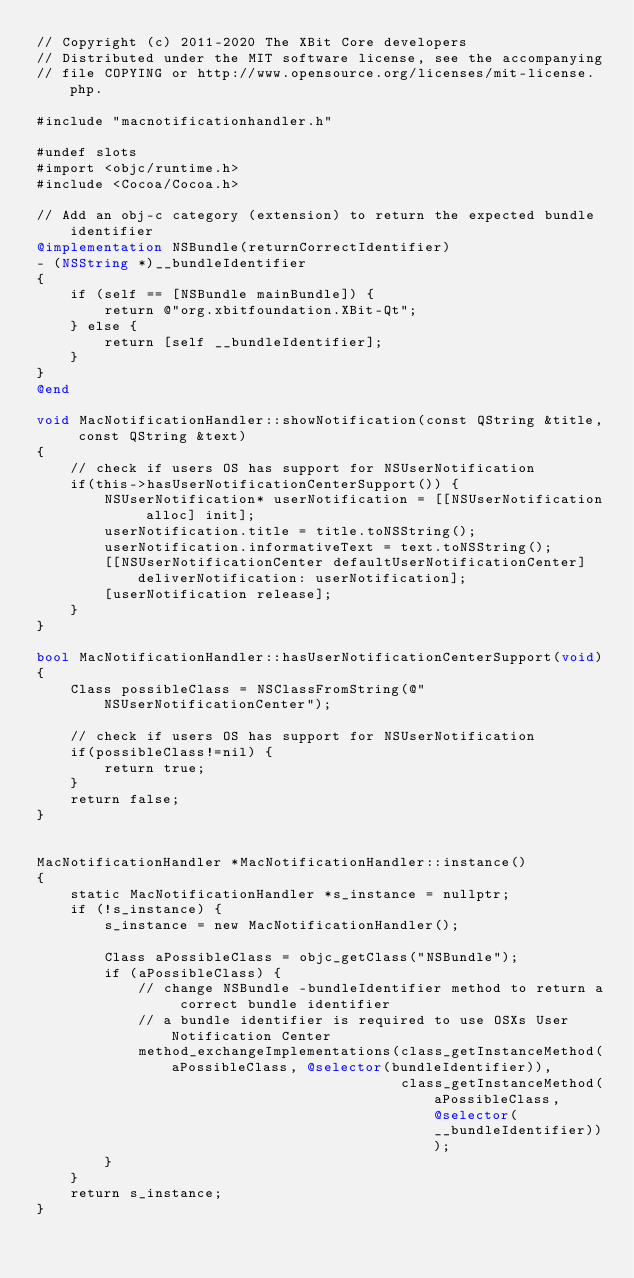<code> <loc_0><loc_0><loc_500><loc_500><_ObjectiveC_>// Copyright (c) 2011-2020 The XBit Core developers
// Distributed under the MIT software license, see the accompanying
// file COPYING or http://www.opensource.org/licenses/mit-license.php.

#include "macnotificationhandler.h"

#undef slots
#import <objc/runtime.h>
#include <Cocoa/Cocoa.h>

// Add an obj-c category (extension) to return the expected bundle identifier
@implementation NSBundle(returnCorrectIdentifier)
- (NSString *)__bundleIdentifier
{
    if (self == [NSBundle mainBundle]) {
        return @"org.xbitfoundation.XBit-Qt";
    } else {
        return [self __bundleIdentifier];
    }
}
@end

void MacNotificationHandler::showNotification(const QString &title, const QString &text)
{
    // check if users OS has support for NSUserNotification
    if(this->hasUserNotificationCenterSupport()) {
        NSUserNotification* userNotification = [[NSUserNotification alloc] init];
        userNotification.title = title.toNSString();
        userNotification.informativeText = text.toNSString();
        [[NSUserNotificationCenter defaultUserNotificationCenter] deliverNotification: userNotification];
        [userNotification release];
    }
}

bool MacNotificationHandler::hasUserNotificationCenterSupport(void)
{
    Class possibleClass = NSClassFromString(@"NSUserNotificationCenter");

    // check if users OS has support for NSUserNotification
    if(possibleClass!=nil) {
        return true;
    }
    return false;
}


MacNotificationHandler *MacNotificationHandler::instance()
{
    static MacNotificationHandler *s_instance = nullptr;
    if (!s_instance) {
        s_instance = new MacNotificationHandler();

        Class aPossibleClass = objc_getClass("NSBundle");
        if (aPossibleClass) {
            // change NSBundle -bundleIdentifier method to return a correct bundle identifier
            // a bundle identifier is required to use OSXs User Notification Center
            method_exchangeImplementations(class_getInstanceMethod(aPossibleClass, @selector(bundleIdentifier)),
                                           class_getInstanceMethod(aPossibleClass, @selector(__bundleIdentifier)));
        }
    }
    return s_instance;
}
</code> 